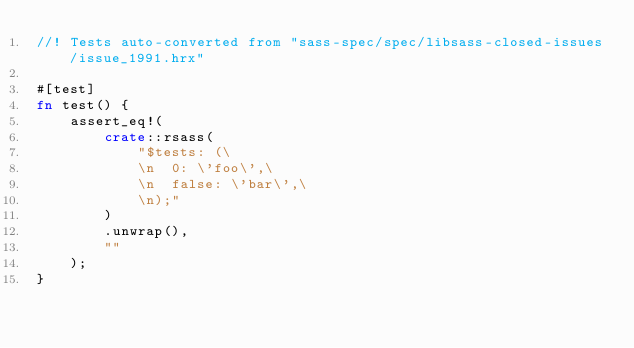Convert code to text. <code><loc_0><loc_0><loc_500><loc_500><_Rust_>//! Tests auto-converted from "sass-spec/spec/libsass-closed-issues/issue_1991.hrx"

#[test]
fn test() {
    assert_eq!(
        crate::rsass(
            "$tests: (\
            \n  0: \'foo\',\
            \n  false: \'bar\',\
            \n);"
        )
        .unwrap(),
        ""
    );
}
</code> 